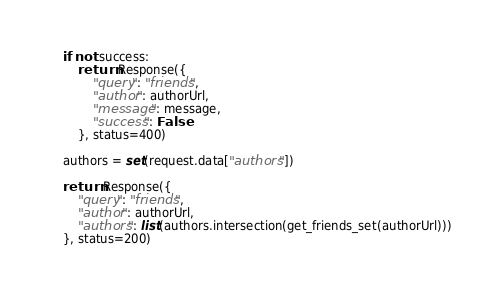<code> <loc_0><loc_0><loc_500><loc_500><_Python_>    if not success:
        return Response({
            "query": "friends",
            "author": authorUrl,
            "message": message,
            "success": False
        }, status=400)

    authors = set(request.data["authors"])

    return Response({
        "query": "friends",
        "author": authorUrl,
        "authors": list(authors.intersection(get_friends_set(authorUrl)))
    }, status=200)
</code> 